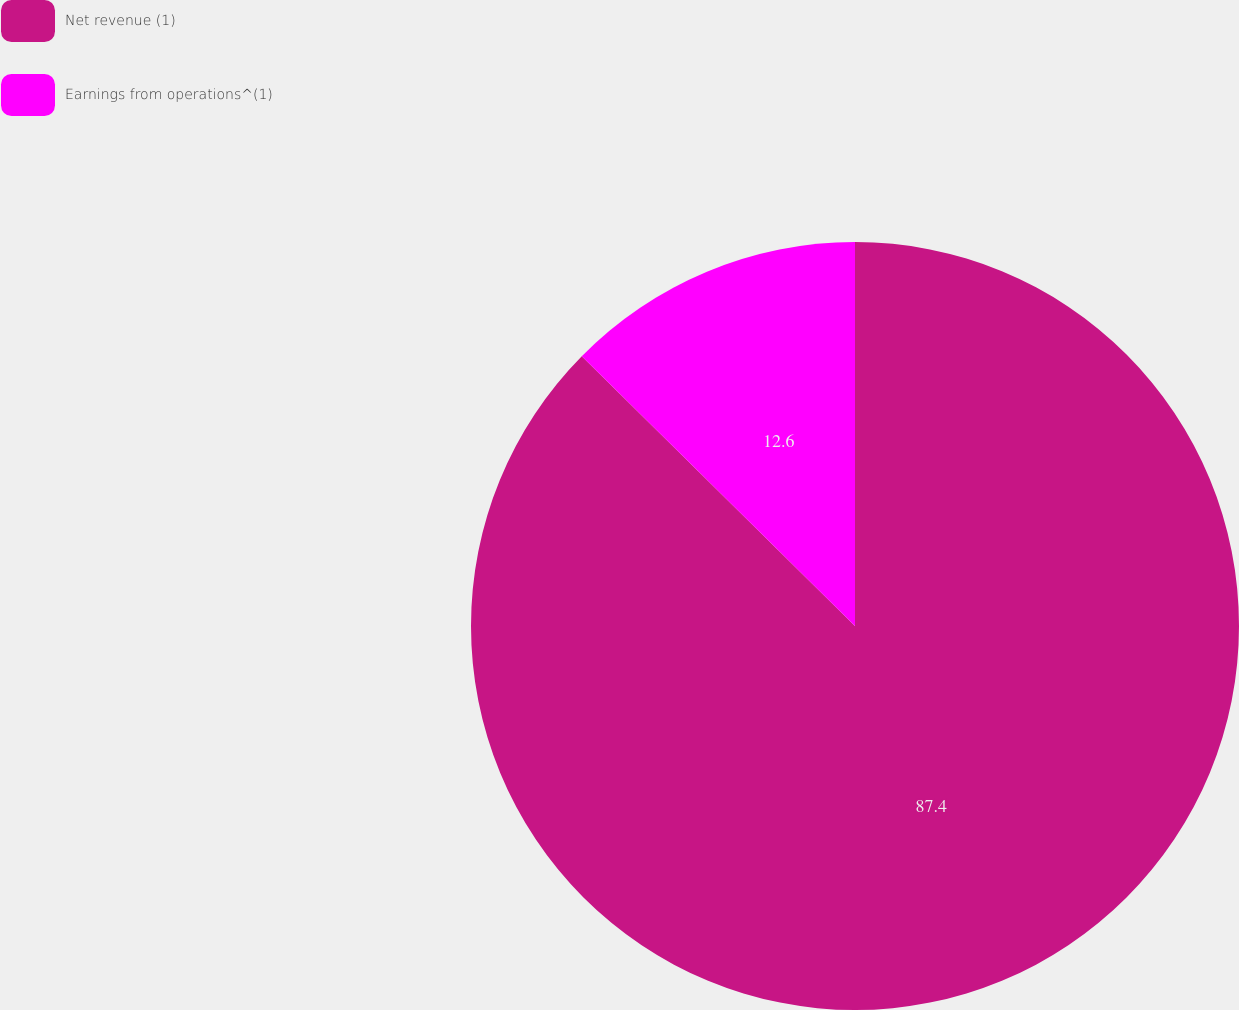Convert chart. <chart><loc_0><loc_0><loc_500><loc_500><pie_chart><fcel>Net revenue (1)<fcel>Earnings from operations^(1)<nl><fcel>87.4%<fcel>12.6%<nl></chart> 